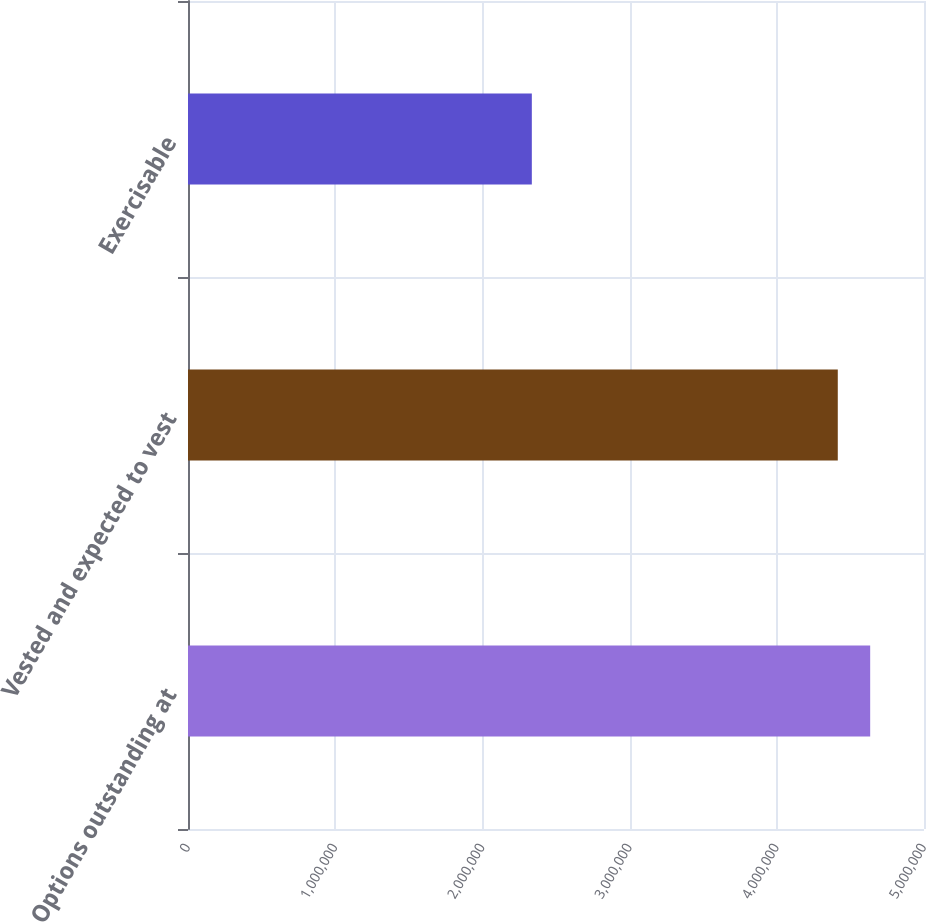Convert chart. <chart><loc_0><loc_0><loc_500><loc_500><bar_chart><fcel>Options outstanding at<fcel>Vested and expected to vest<fcel>Exercisable<nl><fcel>4.63439e+06<fcel>4.4143e+06<fcel>2.3358e+06<nl></chart> 